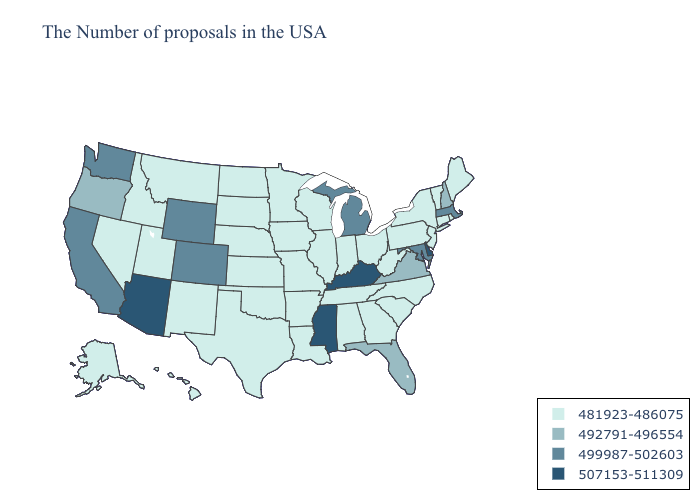Name the states that have a value in the range 492791-496554?
Be succinct. New Hampshire, Virginia, Florida, Oregon. Which states have the lowest value in the USA?
Write a very short answer. Maine, Rhode Island, Vermont, Connecticut, New York, New Jersey, Pennsylvania, North Carolina, South Carolina, West Virginia, Ohio, Georgia, Indiana, Alabama, Tennessee, Wisconsin, Illinois, Louisiana, Missouri, Arkansas, Minnesota, Iowa, Kansas, Nebraska, Oklahoma, Texas, South Dakota, North Dakota, New Mexico, Utah, Montana, Idaho, Nevada, Alaska, Hawaii. What is the highest value in the Northeast ?
Keep it brief. 499987-502603. Does Georgia have the highest value in the USA?
Write a very short answer. No. Name the states that have a value in the range 492791-496554?
Be succinct. New Hampshire, Virginia, Florida, Oregon. Which states hav the highest value in the West?
Concise answer only. Arizona. Does the map have missing data?
Write a very short answer. No. Does Maryland have the lowest value in the USA?
Write a very short answer. No. How many symbols are there in the legend?
Give a very brief answer. 4. Does Alaska have a lower value than Missouri?
Write a very short answer. No. Name the states that have a value in the range 481923-486075?
Give a very brief answer. Maine, Rhode Island, Vermont, Connecticut, New York, New Jersey, Pennsylvania, North Carolina, South Carolina, West Virginia, Ohio, Georgia, Indiana, Alabama, Tennessee, Wisconsin, Illinois, Louisiana, Missouri, Arkansas, Minnesota, Iowa, Kansas, Nebraska, Oklahoma, Texas, South Dakota, North Dakota, New Mexico, Utah, Montana, Idaho, Nevada, Alaska, Hawaii. How many symbols are there in the legend?
Write a very short answer. 4. Does Arizona have the highest value in the West?
Keep it brief. Yes. Does Utah have the highest value in the West?
Short answer required. No. What is the value of Rhode Island?
Answer briefly. 481923-486075. 